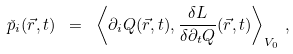Convert formula to latex. <formula><loc_0><loc_0><loc_500><loc_500>\check { p } _ { i } ( \vec { r } , t ) \ = \ \left \langle \partial _ { i } Q ( \vec { r } , t ) , \frac { \delta L } { \delta \partial _ { t } Q } ( \vec { r } , t ) \right \rangle _ { V _ { 0 } } \, ,</formula> 